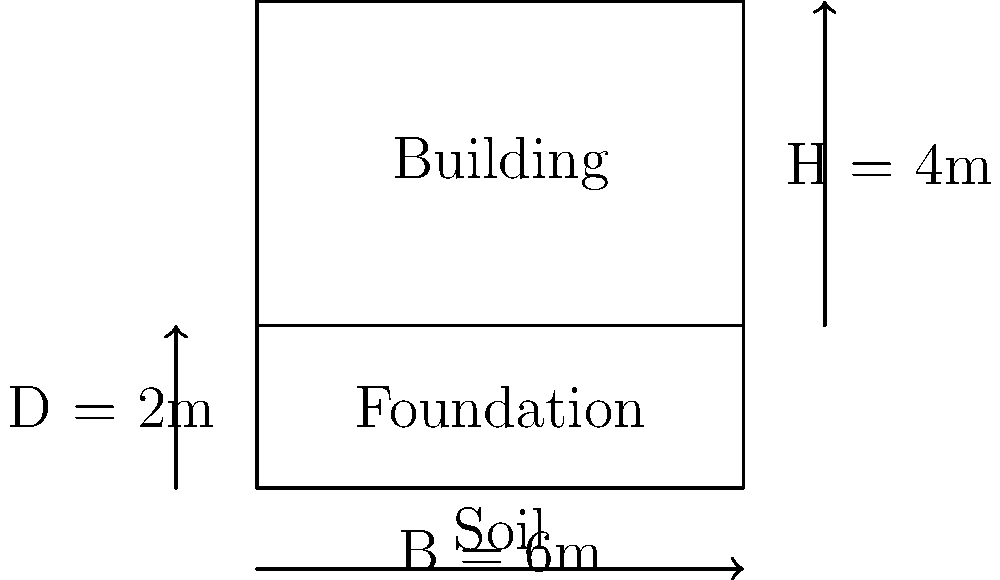A rectangular building with dimensions 6m x 6m and height 4m is supported by a shallow foundation embedded 2m into the ground. The soil beneath the foundation has an elastic modulus (E) of 30 MPa and a Poisson's ratio (ν) of 0.3. Using the elastic settlement equation, estimate the immediate settlement of the foundation in millimeters. Assume a foundation shape factor (Is) of 0.82 and that the net applied pressure (q) is 150 kPa. To estimate the immediate settlement of the foundation, we'll use the elastic settlement equation:

$$ S_e = \frac{q B (1 - \nu^2) I_s}{E} $$

Where:
- $S_e$ is the elastic settlement
- $q$ is the net applied pressure (150 kPa)
- $B$ is the foundation width (6 m)
- $\nu$ is the Poisson's ratio of the soil (0.3)
- $I_s$ is the foundation shape factor (0.82)
- $E$ is the elastic modulus of the soil (30 MPa = 30,000 kPa)

Step 1: Substitute the given values into the equation:

$$ S_e = \frac{150 \times 6 \times (1 - 0.3^2) \times 0.82}{30,000} $$

Step 2: Calculate the numerator:
$$ 150 \times 6 \times (1 - 0.09) \times 0.82 = 672.84 $$

Step 3: Divide by the denominator:
$$ S_e = \frac{672.84}{30,000} = 0.022428 \text{ m} $$

Step 4: Convert the result to millimeters:
$$ S_e = 0.022428 \times 1000 = 22.428 \text{ mm} $$

Step 5: Round to a reasonable number of significant figures:
$$ S_e \approx 22.4 \text{ mm} $$
Answer: 22.4 mm 